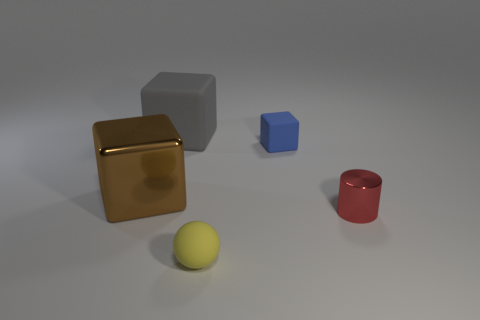How many large objects have the same shape as the tiny blue object?
Your answer should be compact. 2. What material is the small thing that is in front of the shiny object that is right of the brown metal object?
Your answer should be compact. Rubber. Are there any tiny gray blocks made of the same material as the red object?
Ensure brevity in your answer.  No. The small yellow object is what shape?
Keep it short and to the point. Sphere. How many small yellow rubber objects are there?
Provide a short and direct response. 1. What is the color of the rubber thing that is in front of the metal thing that is left of the big gray cube?
Make the answer very short. Yellow. There is another metal thing that is the same size as the gray thing; what color is it?
Your answer should be compact. Brown. Is there a matte ball of the same color as the tiny shiny object?
Provide a short and direct response. No. Are any large brown objects visible?
Provide a short and direct response. Yes. What is the shape of the small thing in front of the tiny metal thing?
Keep it short and to the point. Sphere. 